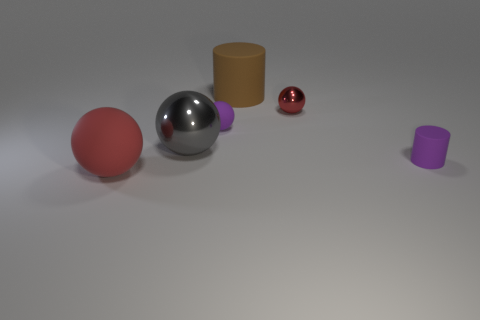How many big rubber cylinders have the same color as the small rubber cylinder?
Offer a terse response. 0. Are there more large gray spheres that are to the right of the gray sphere than big brown things?
Ensure brevity in your answer.  No. There is a big rubber object on the left side of the purple matte thing left of the tiny metallic thing; what color is it?
Keep it short and to the point. Red. What number of things are small purple things that are behind the big gray sphere or large matte things to the left of the large gray metallic ball?
Keep it short and to the point. 2. What color is the tiny shiny thing?
Make the answer very short. Red. What number of objects are the same material as the purple cylinder?
Your response must be concise. 3. Are there more large purple metal cylinders than large balls?
Give a very brief answer. No. How many red things are in front of the red sphere to the left of the red metal thing?
Offer a very short reply. 0. How many things are either things that are behind the red rubber sphere or tiny cyan shiny spheres?
Keep it short and to the point. 5. Are there any brown things of the same shape as the red shiny object?
Ensure brevity in your answer.  No. 